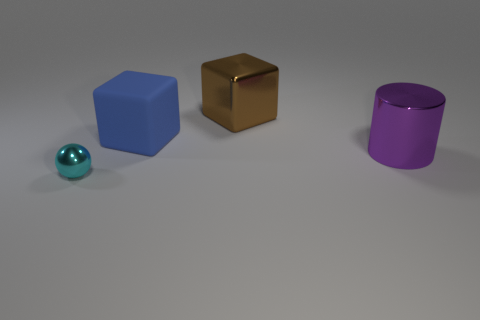Subtract all cyan balls. How many brown cubes are left? 1 Subtract 1 blocks. How many blocks are left? 1 Subtract all gray cylinders. Subtract all brown spheres. How many cylinders are left? 1 Subtract all tiny metal things. Subtract all purple cylinders. How many objects are left? 2 Add 3 blocks. How many blocks are left? 5 Add 2 tiny gray shiny objects. How many tiny gray shiny objects exist? 2 Add 3 big red cylinders. How many objects exist? 7 Subtract 0 purple balls. How many objects are left? 4 Subtract all spheres. How many objects are left? 3 